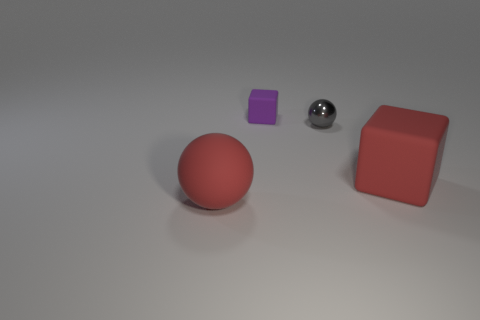What number of tiny gray shiny objects are left of the large red rubber thing to the right of the ball right of the small rubber thing? There is one small gray shiny sphere located to the left of the large red cube, which is positioned to the right of the red sphere, which is in turn to the right of the small purple cube. 